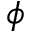<formula> <loc_0><loc_0><loc_500><loc_500>\phi</formula> 